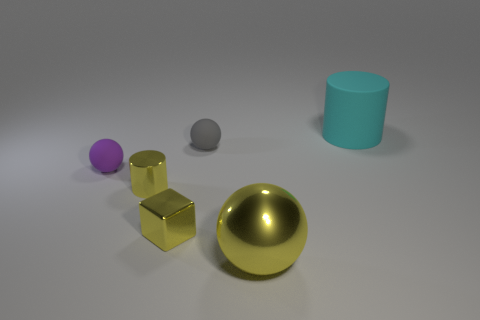Add 4 big cyan cylinders. How many objects exist? 10 Subtract all yellow balls. How many balls are left? 2 Subtract all yellow spheres. How many spheres are left? 2 Subtract all cubes. How many objects are left? 5 Subtract 1 cylinders. How many cylinders are left? 1 Subtract 0 gray cubes. How many objects are left? 6 Subtract all cyan balls. Subtract all red cylinders. How many balls are left? 3 Subtract all gray cubes. How many gray spheres are left? 1 Subtract all large yellow metallic things. Subtract all tiny rubber objects. How many objects are left? 3 Add 2 tiny rubber objects. How many tiny rubber objects are left? 4 